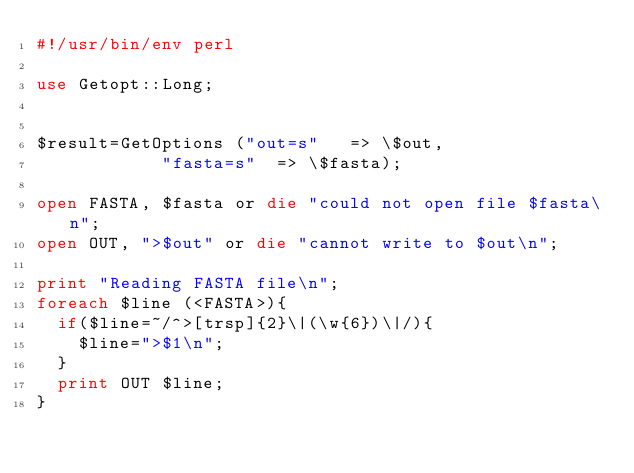<code> <loc_0><loc_0><loc_500><loc_500><_Perl_>#!/usr/bin/env perl

use Getopt::Long;


$result=GetOptions ("out=s"   => \$out,
		    "fasta=s"  => \$fasta);

open FASTA, $fasta or die "could not open file $fasta\n";
open OUT, ">$out" or die "cannot write to $out\n";

print "Reading FASTA file\n";
foreach $line (<FASTA>){
  if($line=~/^>[trsp]{2}\|(\w{6})\|/){
    $line=">$1\n";
  }
  print OUT $line;
}
</code> 